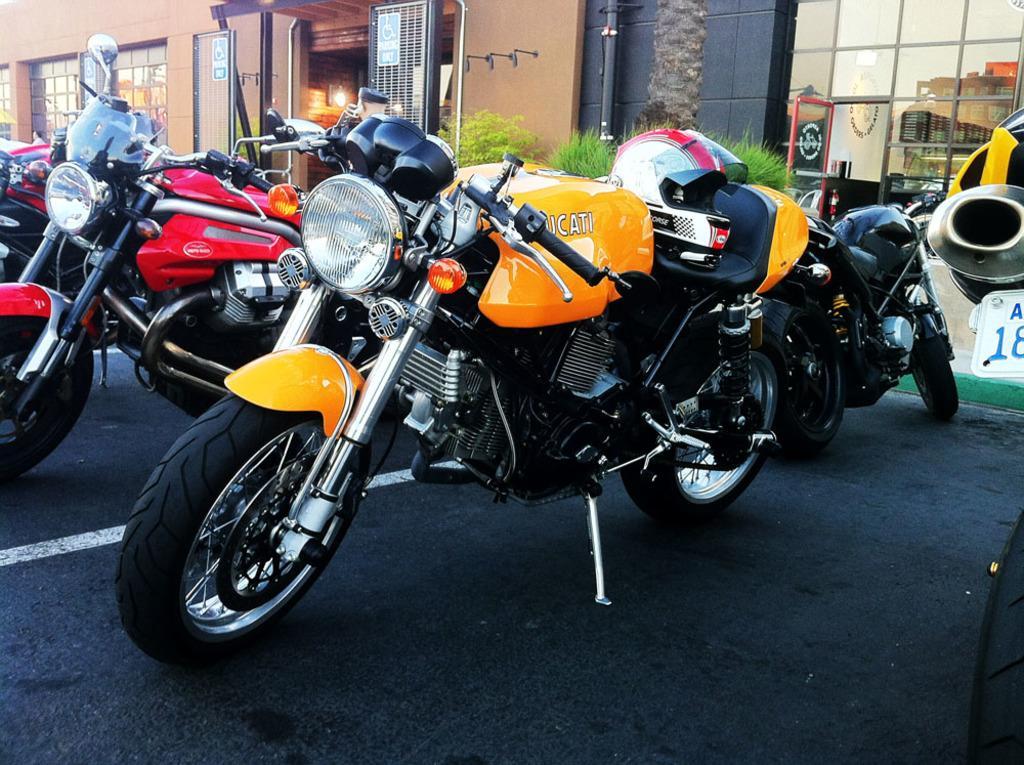In one or two sentences, can you explain what this image depicts? This picture is clicked outside. In the center we can see the group of bikes parked on the ground. In the background we can see the buildings, a person like thing, light and some other objects and we can see the reflections of the sky and buildings on the glasses. 